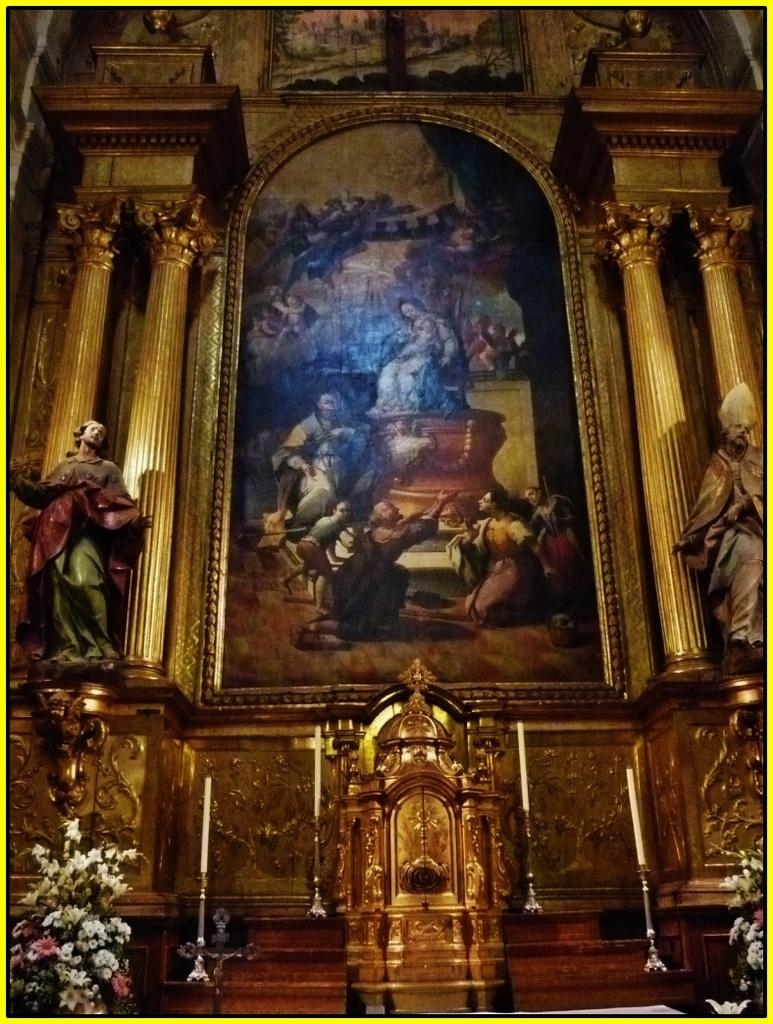What type of decorative items can be seen in the image? There are flower bouquets, statues, candles, and pictures in the image. What architectural elements are present in the image? There are pillars in the image. What type of wall can be seen in the image? There is a designed wall in the image. What is the income of the person who placed the candles in the image? There is no information about the person who placed the candles in the image, nor is there any information about their income. --- Facts: 1. There is a person sitting on a chair in the image. 2. The person is holding a book. 3. There is a table next to the chair. 4. There is a lamp on the table. 5. The background of the image is a bookshelf. Absurd Topics: parrot, ocean, bicycle Conversation: What is the person in the image doing? The person in the image is sitting on a chair and holding a book. What object is next to the chair? There is a table next to the chair. What is on the table? There is a lamp on the table. What can be seen in the background of the image? The background of the image is a bookshelf. Reasoning: Let's think step by step in order to produce the conversation. We start by describing the person's actions and the objects they are interacting with, such as the chair and the book. Then, we mention the presence of the table and the lamp on it. Finally, we describe the background of the image, which is a bookshelf. Absurd Question/Answer: Can you see a parrot sitting on the person's shoulder in the image? No, there is no parrot present in the image. 